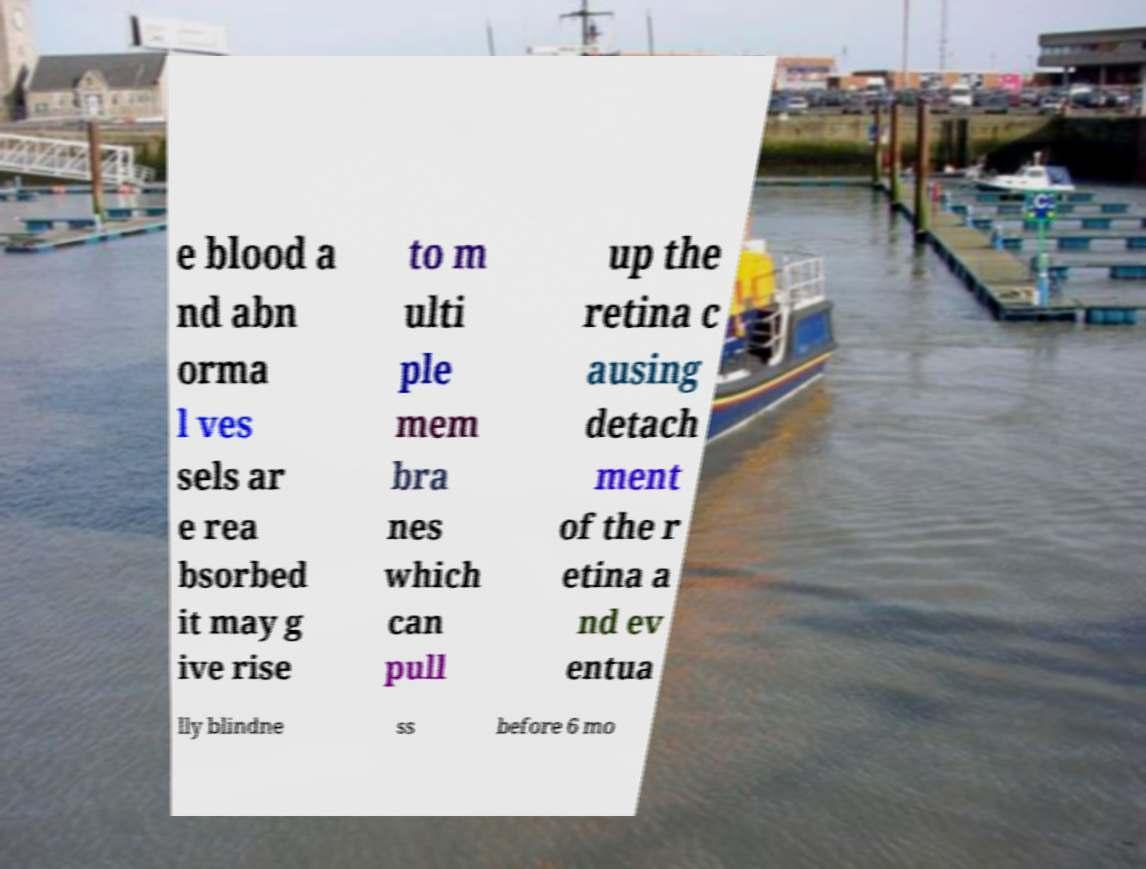I need the written content from this picture converted into text. Can you do that? e blood a nd abn orma l ves sels ar e rea bsorbed it may g ive rise to m ulti ple mem bra nes which can pull up the retina c ausing detach ment of the r etina a nd ev entua lly blindne ss before 6 mo 